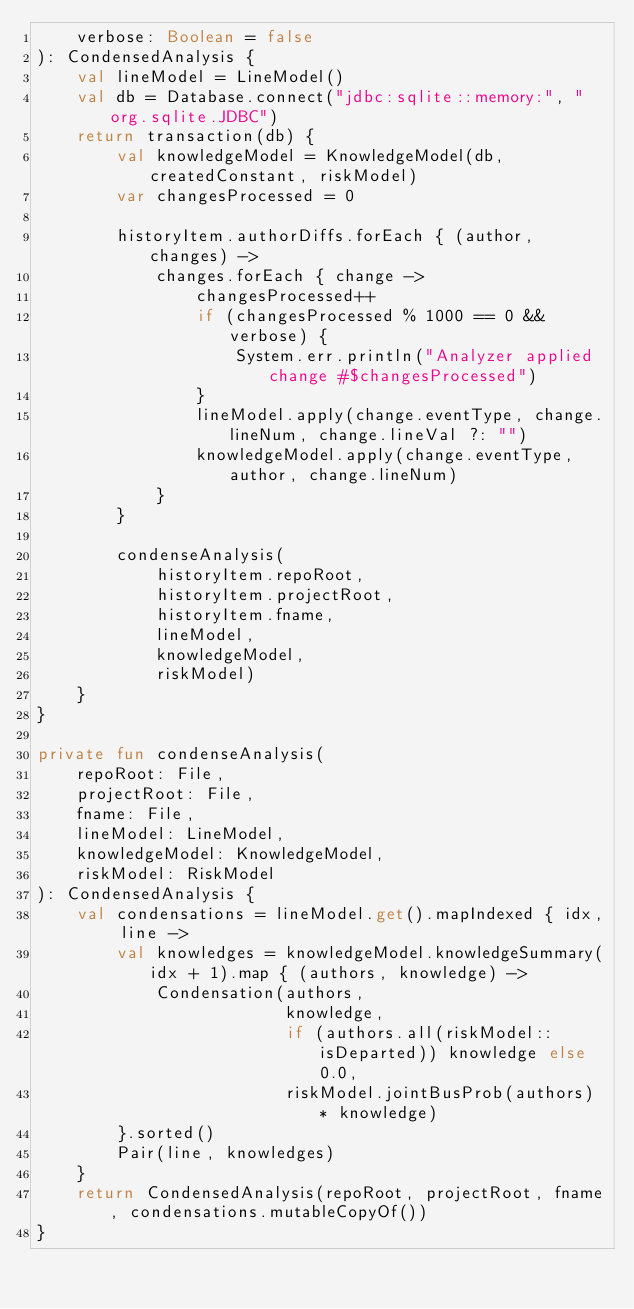<code> <loc_0><loc_0><loc_500><loc_500><_Kotlin_>    verbose: Boolean = false
): CondensedAnalysis {
    val lineModel = LineModel()
    val db = Database.connect("jdbc:sqlite::memory:", "org.sqlite.JDBC")
    return transaction(db) {
        val knowledgeModel = KnowledgeModel(db, createdConstant, riskModel)
        var changesProcessed = 0

        historyItem.authorDiffs.forEach { (author, changes) ->
            changes.forEach { change ->
                changesProcessed++
                if (changesProcessed % 1000 == 0 && verbose) {
                    System.err.println("Analyzer applied change #$changesProcessed")
                }
                lineModel.apply(change.eventType, change.lineNum, change.lineVal ?: "")
                knowledgeModel.apply(change.eventType, author, change.lineNum)
            }
        }

        condenseAnalysis(
            historyItem.repoRoot,
            historyItem.projectRoot,
            historyItem.fname,
            lineModel,
            knowledgeModel,
            riskModel)
    }
}

private fun condenseAnalysis(
    repoRoot: File,
    projectRoot: File,
    fname: File,
    lineModel: LineModel,
    knowledgeModel: KnowledgeModel,
    riskModel: RiskModel
): CondensedAnalysis {
    val condensations = lineModel.get().mapIndexed { idx, line ->
        val knowledges = knowledgeModel.knowledgeSummary(idx + 1).map { (authors, knowledge) ->
            Condensation(authors,
                         knowledge,
                         if (authors.all(riskModel::isDeparted)) knowledge else 0.0,
                         riskModel.jointBusProb(authors) * knowledge)
        }.sorted()
        Pair(line, knowledges)
    }
    return CondensedAnalysis(repoRoot, projectRoot, fname, condensations.mutableCopyOf())
}
</code> 